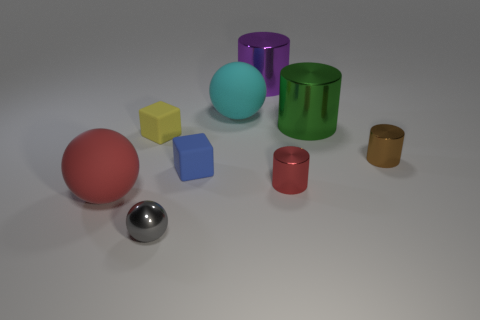Is there any other thing that has the same shape as the blue object?
Your answer should be very brief. Yes. What is the color of the other small object that is the same shape as the yellow object?
Your response must be concise. Blue. What is the shape of the metallic thing on the left side of the big purple thing?
Make the answer very short. Sphere. Are there any purple objects in front of the brown shiny cylinder?
Your response must be concise. No. Are there any other things that are the same size as the brown metal object?
Offer a terse response. Yes. The other ball that is the same material as the red ball is what color?
Offer a very short reply. Cyan. There is a rubber ball on the left side of the small yellow thing; is it the same color as the big sphere that is behind the tiny yellow rubber object?
Make the answer very short. No. What number of cylinders are either tiny yellow things or large rubber objects?
Offer a terse response. 0. Are there an equal number of big metallic things that are on the right side of the purple thing and small brown objects?
Provide a succinct answer. Yes. There is a object in front of the big matte object that is to the left of the matte cube behind the tiny blue cube; what is its material?
Ensure brevity in your answer.  Metal. 